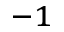<formula> <loc_0><loc_0><loc_500><loc_500>^ { - 1 }</formula> 